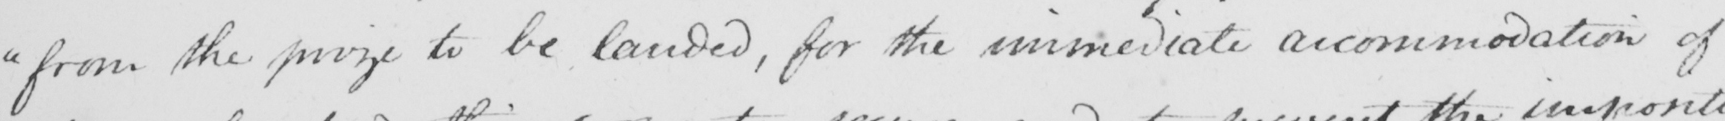Please transcribe the handwritten text in this image. " from the prize to be landed , for the immediate accommodation of 